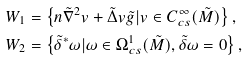<formula> <loc_0><loc_0><loc_500><loc_500>W _ { 1 } & = \left \{ n \tilde { \nabla } ^ { 2 } v + \tilde { \Delta } v \tilde { g } | v \in C ^ { \infty } _ { c s } ( \tilde { M } ) \right \} , \\ W _ { 2 } & = \left \{ \tilde { \delta } ^ { * } \omega | \omega \in \Omega ^ { 1 } _ { c s } ( \tilde { M } ) , \tilde { \delta } \omega = 0 \right \} ,</formula> 